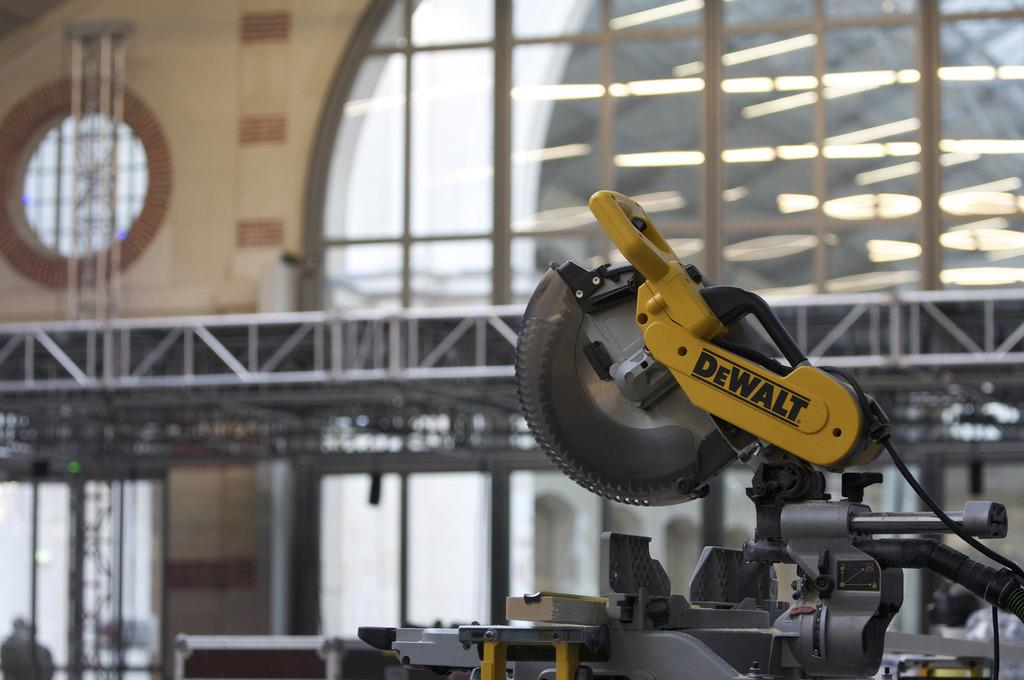<image>
Offer a succinct explanation of the picture presented. A Dewalt saw that is on a table in a room. 